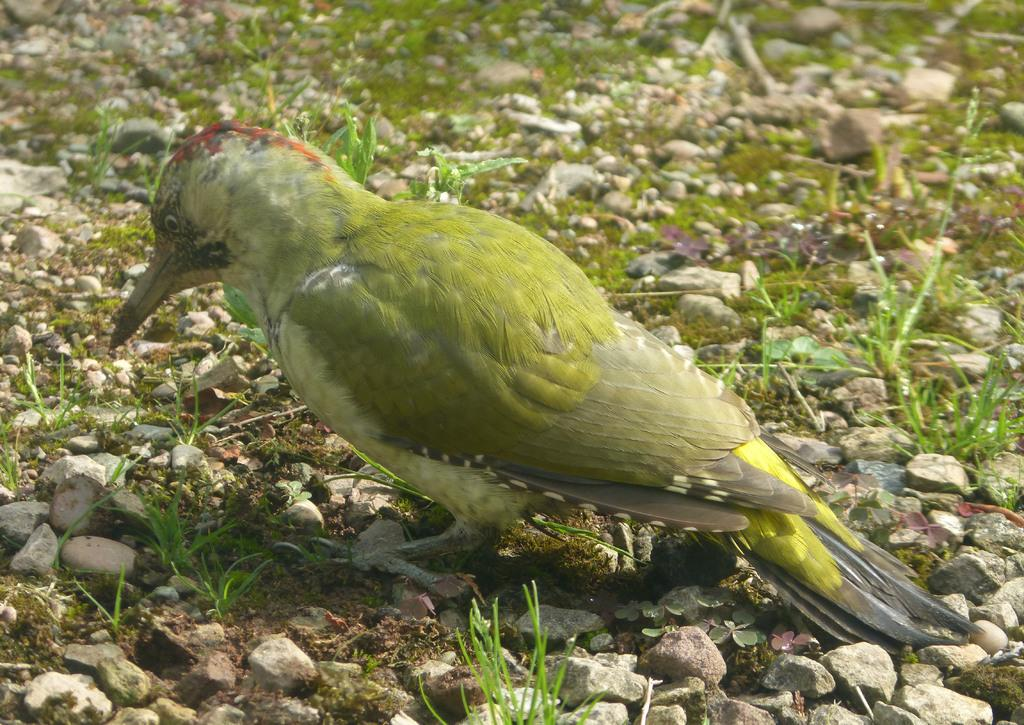What type of animal is on the ground in the image? There is a bird on the ground in the image. What can be seen in the background of the image? There is grass and stones in the background of the image. Where is the sink located in the image? There is no sink present in the image. What type of club can be seen in the image? There is no club present in the image. 